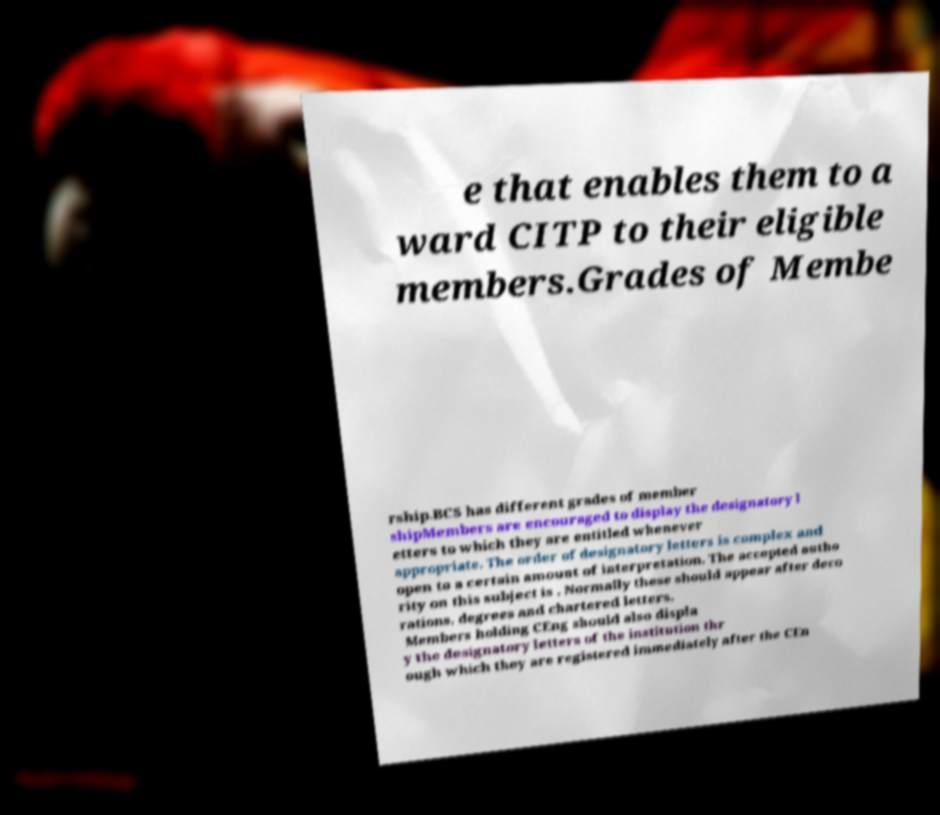Can you read and provide the text displayed in the image?This photo seems to have some interesting text. Can you extract and type it out for me? e that enables them to a ward CITP to their eligible members.Grades of Membe rship.BCS has different grades of member shipMembers are encouraged to display the designatory l etters to which they are entitled whenever appropriate. The order of designatory letters is complex and open to a certain amount of interpretation. The accepted autho rity on this subject is . Normally these should appear after deco rations, degrees and chartered letters. Members holding CEng should also displa y the designatory letters of the institution thr ough which they are registered immediately after the CEn 